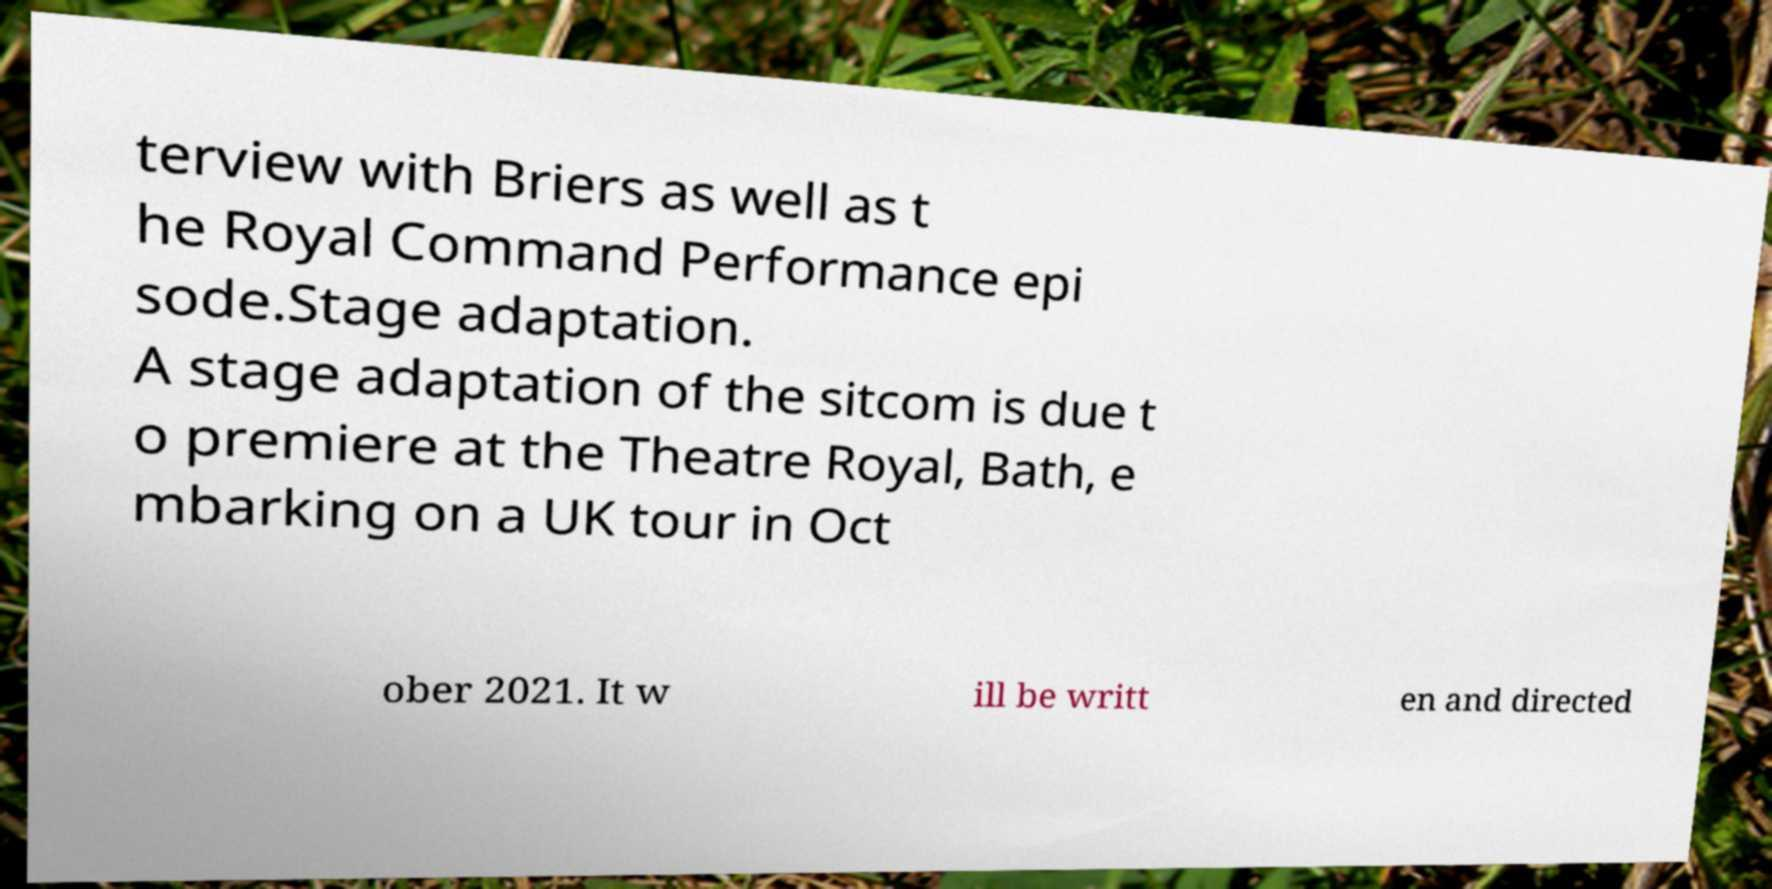Could you extract and type out the text from this image? terview with Briers as well as t he Royal Command Performance epi sode.Stage adaptation. A stage adaptation of the sitcom is due t o premiere at the Theatre Royal, Bath, e mbarking on a UK tour in Oct ober 2021. It w ill be writt en and directed 